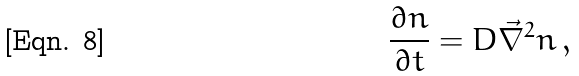<formula> <loc_0><loc_0><loc_500><loc_500>\frac { \partial n } { \partial t } = D \vec { \nabla } ^ { 2 } n \, ,</formula> 